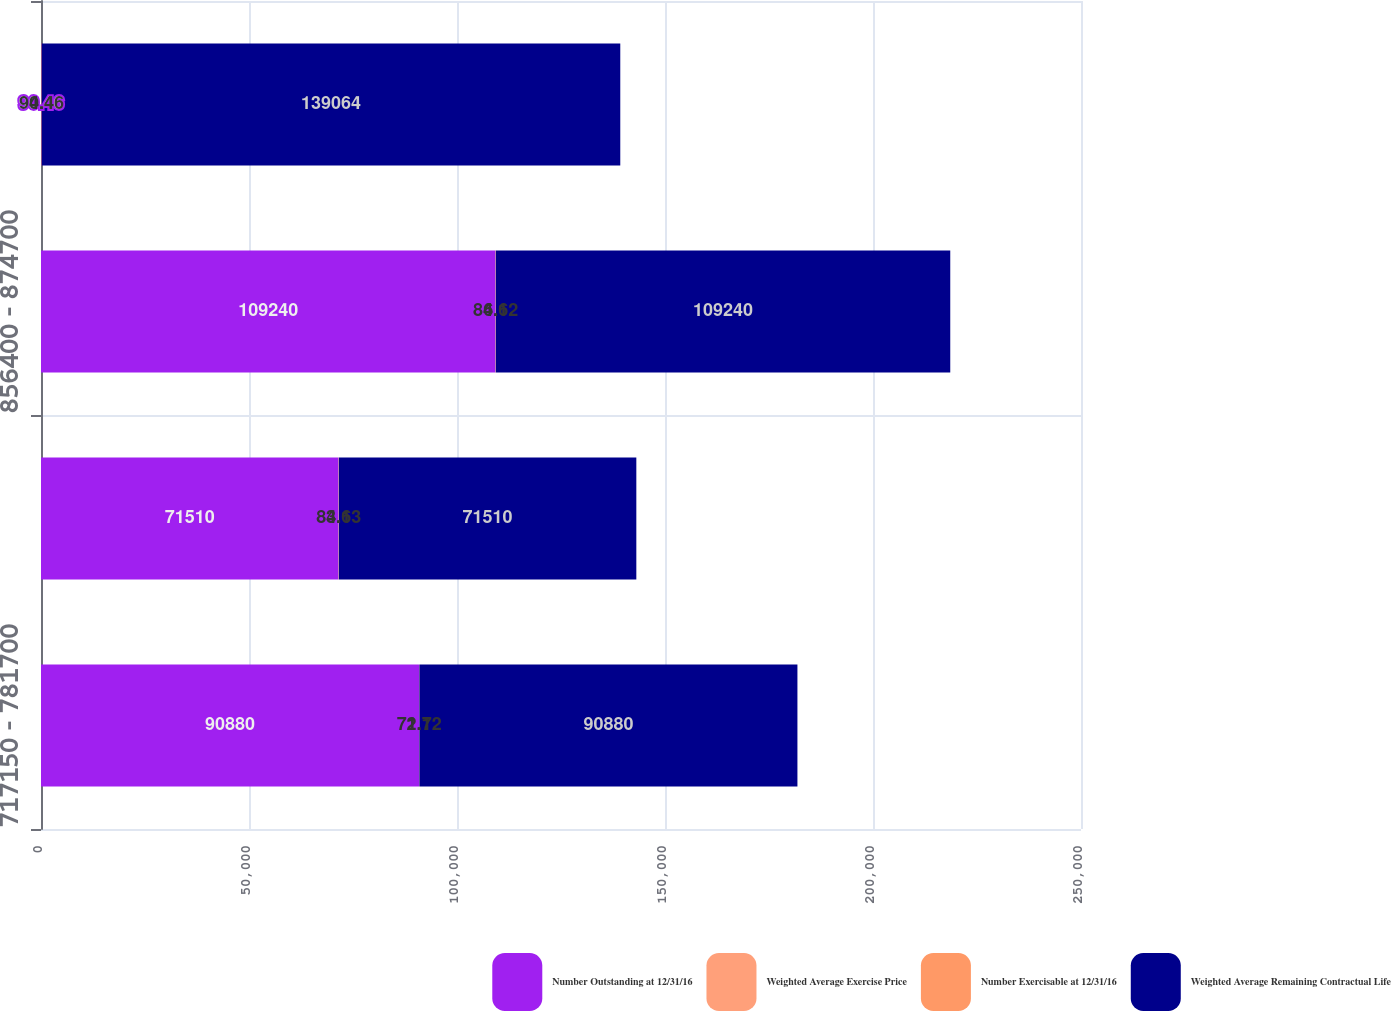Convert chart. <chart><loc_0><loc_0><loc_500><loc_500><stacked_bar_chart><ecel><fcel>717150 - 781700<fcel>781800 - 856300<fcel>856400 - 874700<fcel>874800 - 1101300<nl><fcel>Number Outstanding at 12/31/16<fcel>90880<fcel>71510<fcel>109240<fcel>90.46<nl><fcel>Weighted Average Exercise Price<fcel>2.1<fcel>3.1<fcel>4.1<fcel>4.4<nl><fcel>Number Exercisable at 12/31/16<fcel>71.72<fcel>84.63<fcel>86.62<fcel>90.46<nl><fcel>Weighted Average Remaining Contractual Life<fcel>90880<fcel>71510<fcel>109240<fcel>139064<nl></chart> 